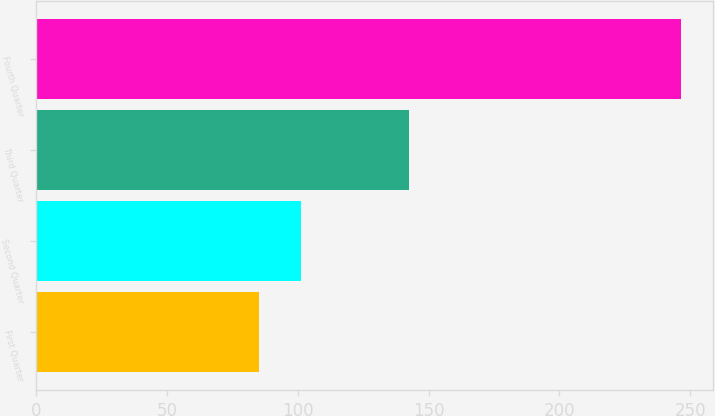Convert chart. <chart><loc_0><loc_0><loc_500><loc_500><bar_chart><fcel>First Quarter<fcel>Second Quarter<fcel>Third Quarter<fcel>Fourth Quarter<nl><fcel>85.33<fcel>101.43<fcel>142.6<fcel>246.35<nl></chart> 